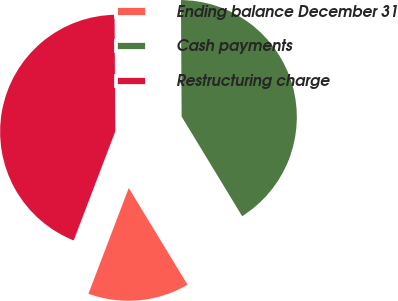<chart> <loc_0><loc_0><loc_500><loc_500><pie_chart><fcel>Ending balance December 31<fcel>Cash payments<fcel>Restructuring charge<nl><fcel>14.49%<fcel>41.41%<fcel>44.1%<nl></chart> 